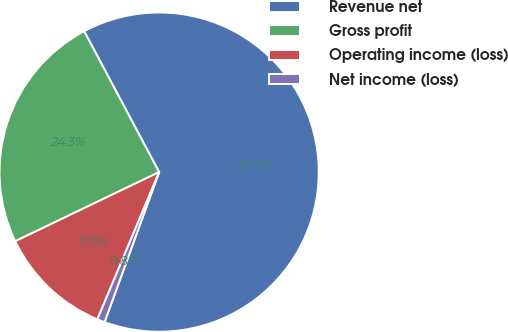<chart> <loc_0><loc_0><loc_500><loc_500><pie_chart><fcel>Revenue net � � � � � � � � �<fcel>Gross profit � � � � � � � � �<fcel>Operating income (loss) � � �<fcel>Net income (loss) � � � � � �<nl><fcel>63.34%<fcel>24.35%<fcel>11.55%<fcel>0.77%<nl></chart> 